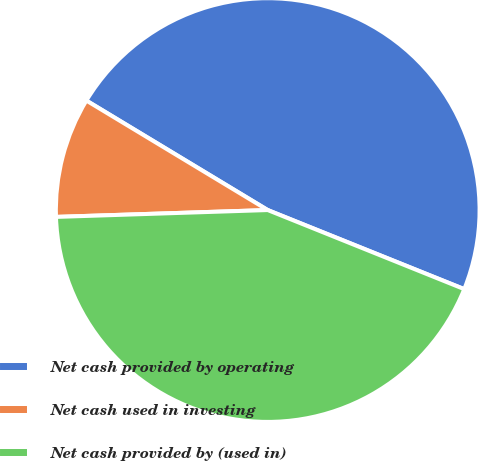<chart> <loc_0><loc_0><loc_500><loc_500><pie_chart><fcel>Net cash provided by operating<fcel>Net cash used in investing<fcel>Net cash provided by (used in)<nl><fcel>47.45%<fcel>9.16%<fcel>43.4%<nl></chart> 